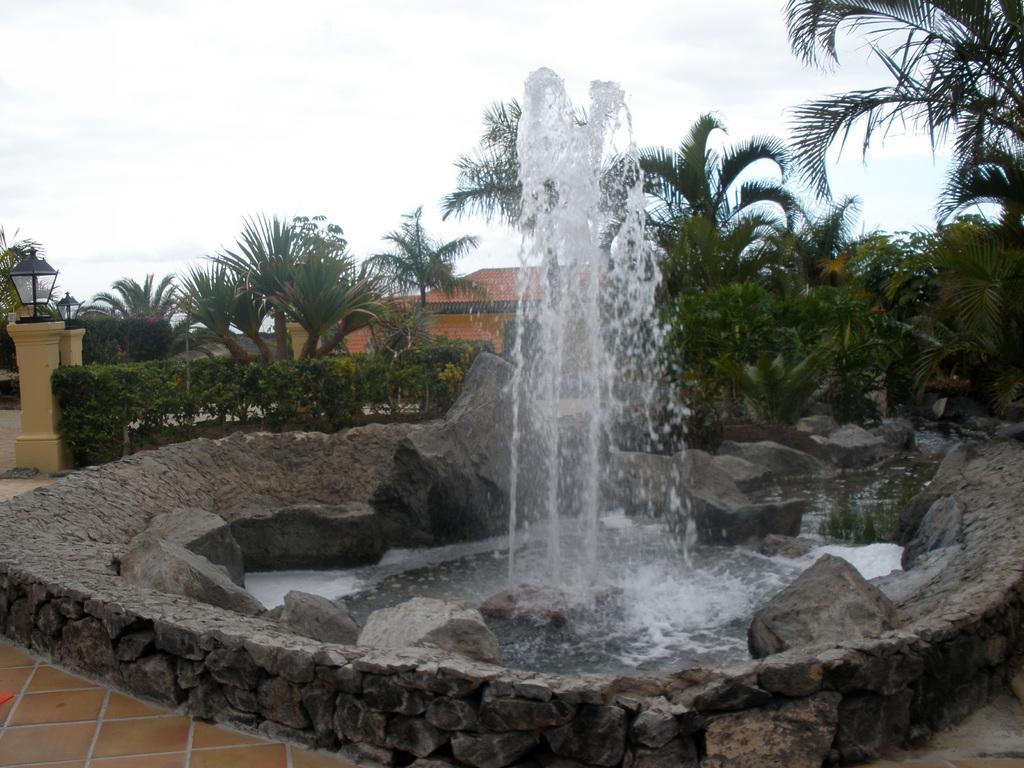Describe this image in one or two sentences. In this picture there is a fountain and rocks in the center of the image and there are houses and trees in the background area of the image, there are lamp pillars on the left side of the image. 